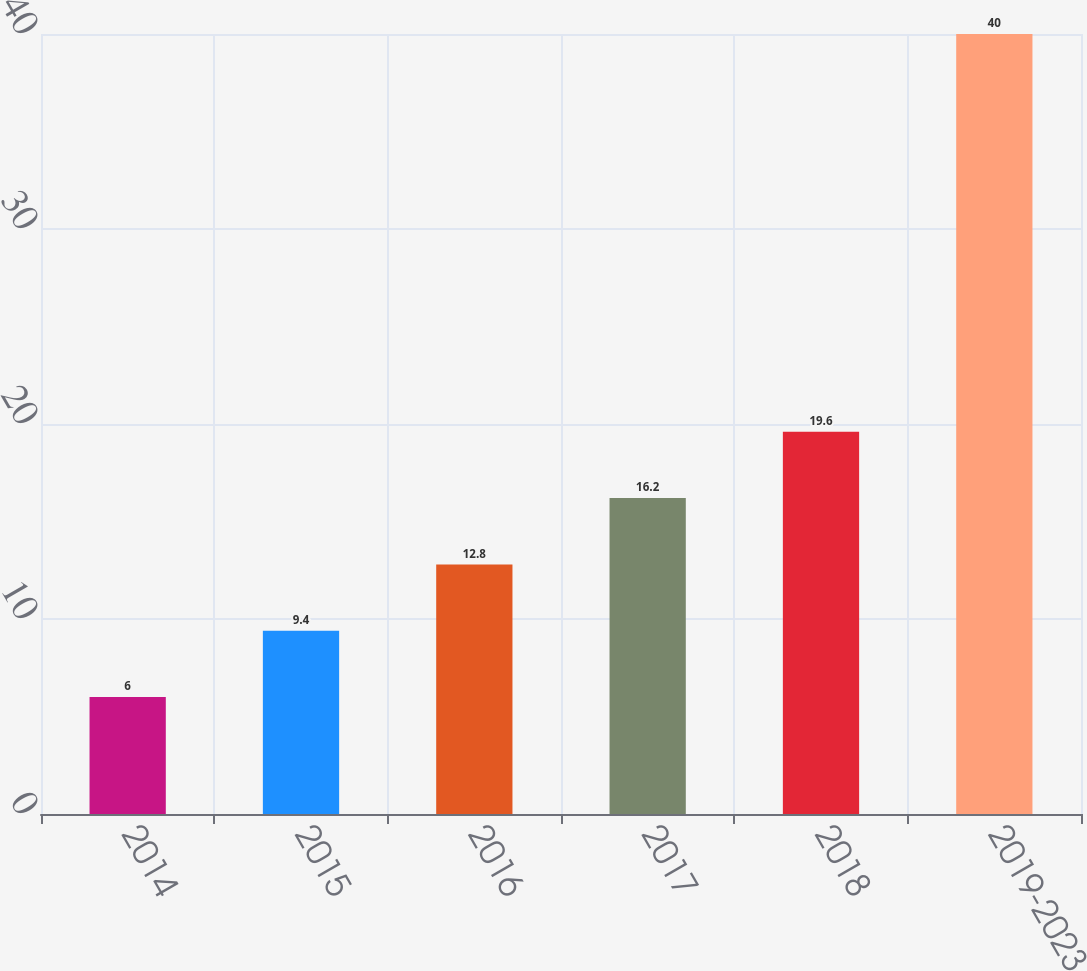Convert chart. <chart><loc_0><loc_0><loc_500><loc_500><bar_chart><fcel>2014<fcel>2015<fcel>2016<fcel>2017<fcel>2018<fcel>2019-2023<nl><fcel>6<fcel>9.4<fcel>12.8<fcel>16.2<fcel>19.6<fcel>40<nl></chart> 